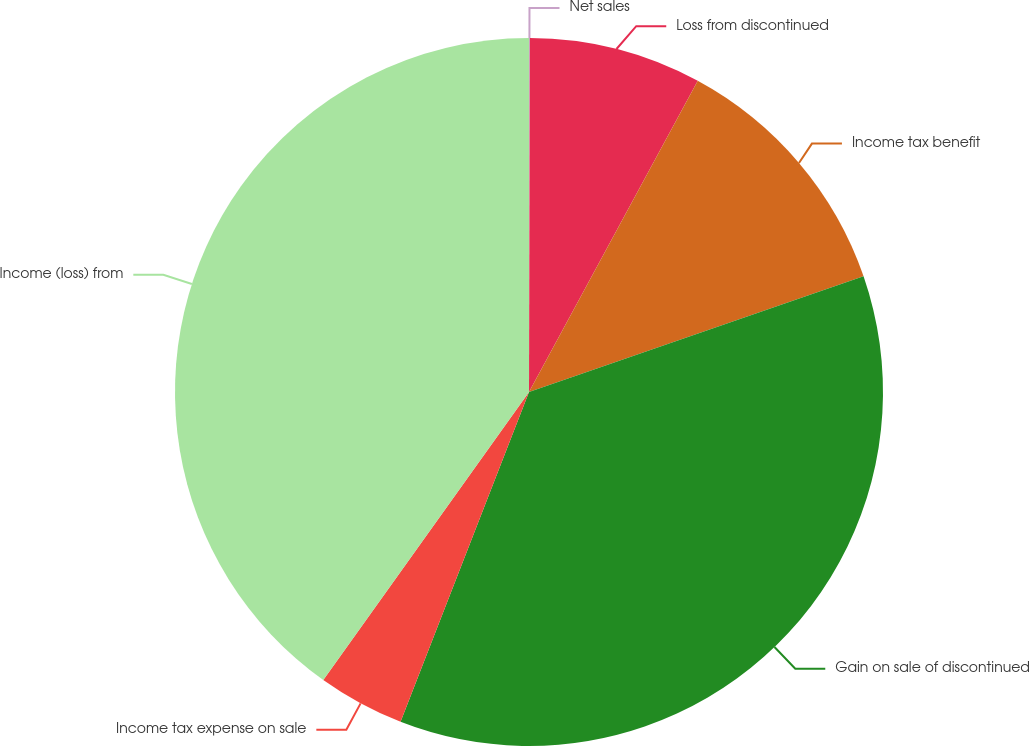Convert chart to OTSL. <chart><loc_0><loc_0><loc_500><loc_500><pie_chart><fcel>Net sales<fcel>Loss from discontinued<fcel>Income tax benefit<fcel>Gain on sale of discontinued<fcel>Income tax expense on sale<fcel>Income (loss) from<nl><fcel>0.04%<fcel>7.87%<fcel>11.79%<fcel>36.21%<fcel>3.96%<fcel>40.13%<nl></chart> 